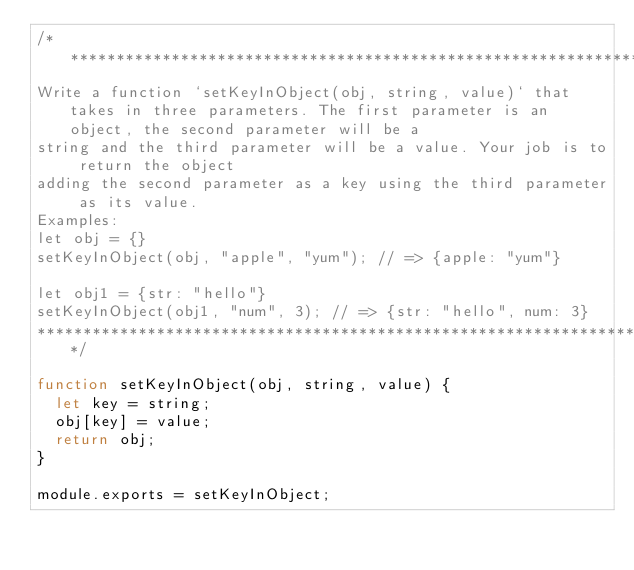Convert code to text. <code><loc_0><loc_0><loc_500><loc_500><_JavaScript_>/***********************************************************************
Write a function `setKeyInObject(obj, string, value)` that takes in three parameters. The first parameter is an object, the second parameter will be a 
string and the third parameter will be a value. Your job is to return the object
adding the second parameter as a key using the third parameter as its value.
Examples:
let obj = {}
setKeyInObject(obj, "apple", "yum"); // => {apple: "yum"}

let obj1 = {str: "hello"}
setKeyInObject(obj1, "num", 3); // => {str: "hello", num: 3}
***********************************************************************/

function setKeyInObject(obj, string, value) {
  let key = string;
  obj[key] = value;
  return obj;
}

module.exports = setKeyInObject;
</code> 